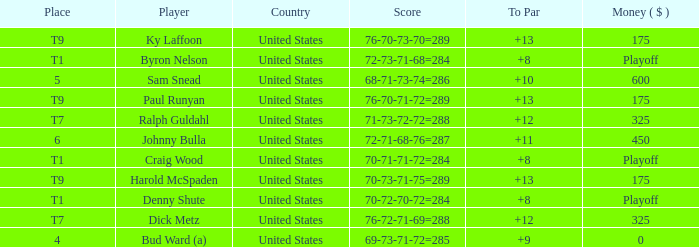What was the total To Par for Craig Wood? 8.0. 